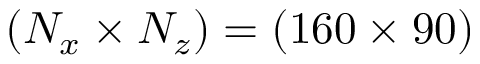<formula> <loc_0><loc_0><loc_500><loc_500>( N _ { x } \times N _ { z } ) = ( 1 6 0 \times 9 0 )</formula> 